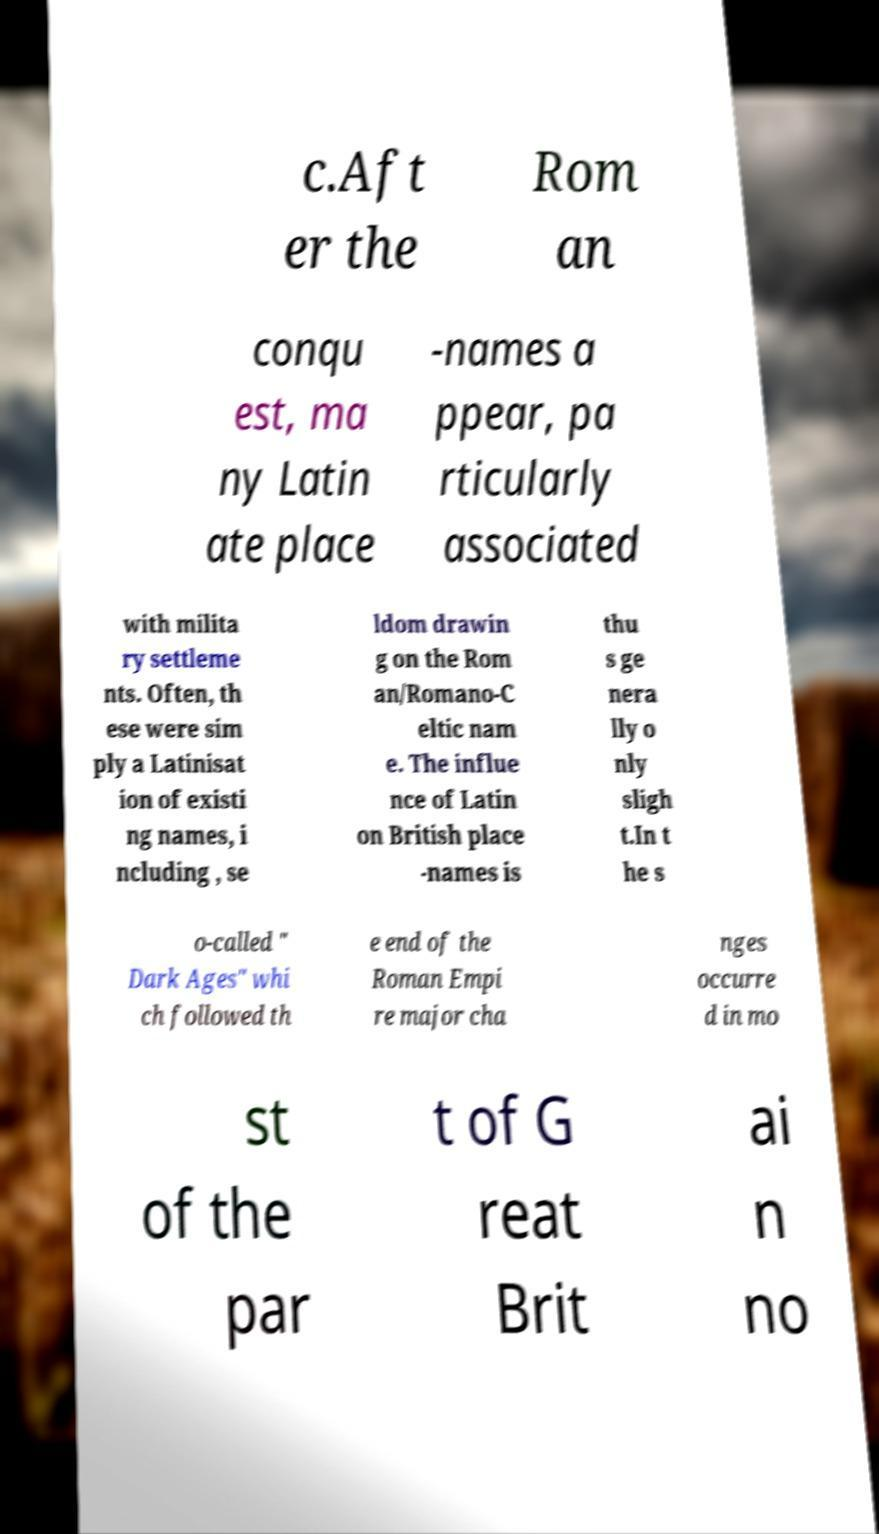Please read and relay the text visible in this image. What does it say? c.Aft er the Rom an conqu est, ma ny Latin ate place -names a ppear, pa rticularly associated with milita ry settleme nts. Often, th ese were sim ply a Latinisat ion of existi ng names, i ncluding , se ldom drawin g on the Rom an/Romano-C eltic nam e. The influe nce of Latin on British place -names is thu s ge nera lly o nly sligh t.In t he s o-called " Dark Ages" whi ch followed th e end of the Roman Empi re major cha nges occurre d in mo st of the par t of G reat Brit ai n no 